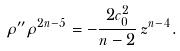<formula> <loc_0><loc_0><loc_500><loc_500>\rho ^ { \prime \prime } \rho ^ { 2 n - 5 } = - \frac { 2 c _ { 0 } ^ { 2 } } { n - 2 } \, z ^ { n - 4 } .</formula> 